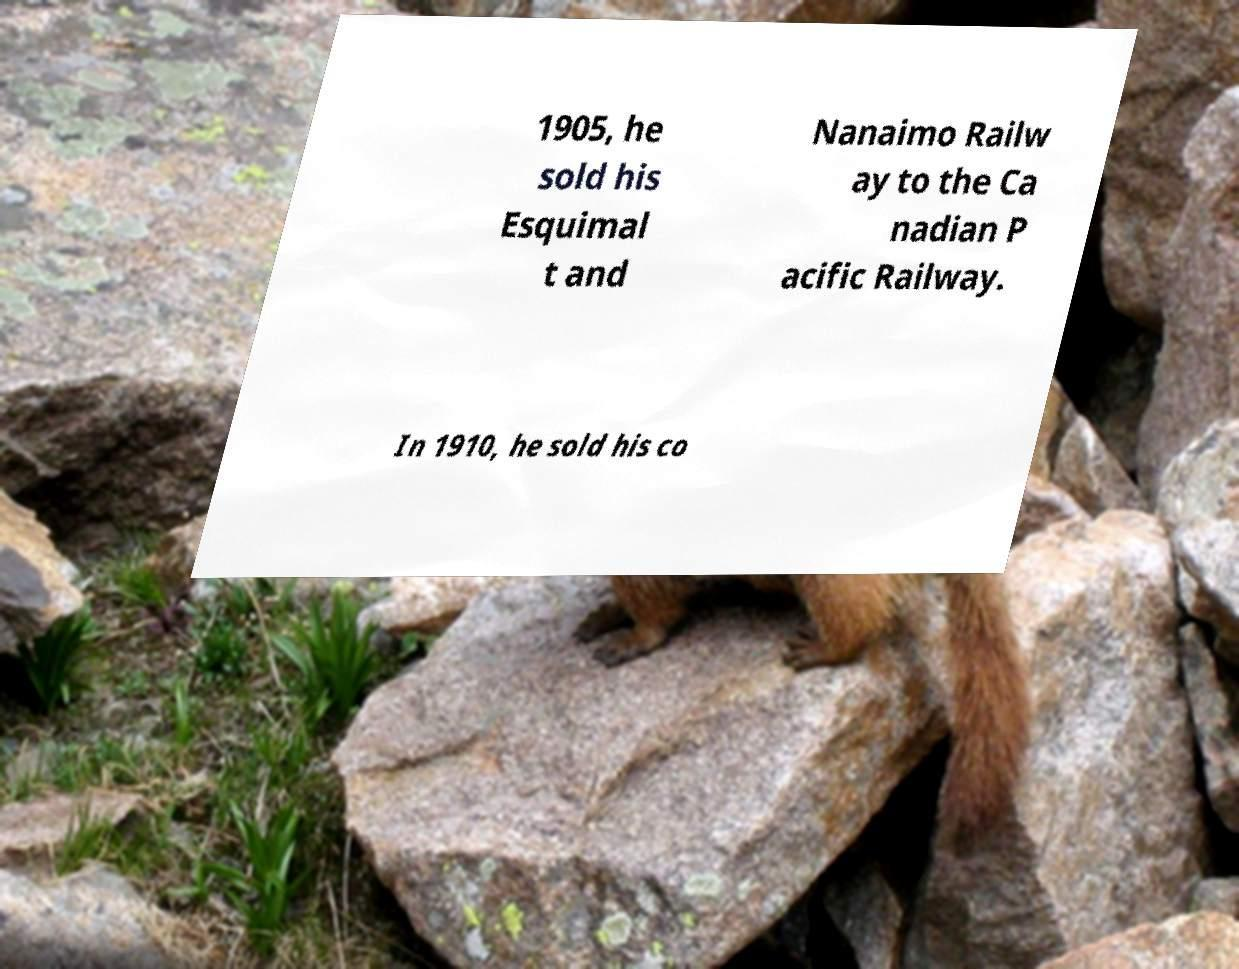I need the written content from this picture converted into text. Can you do that? 1905, he sold his Esquimal t and Nanaimo Railw ay to the Ca nadian P acific Railway. In 1910, he sold his co 